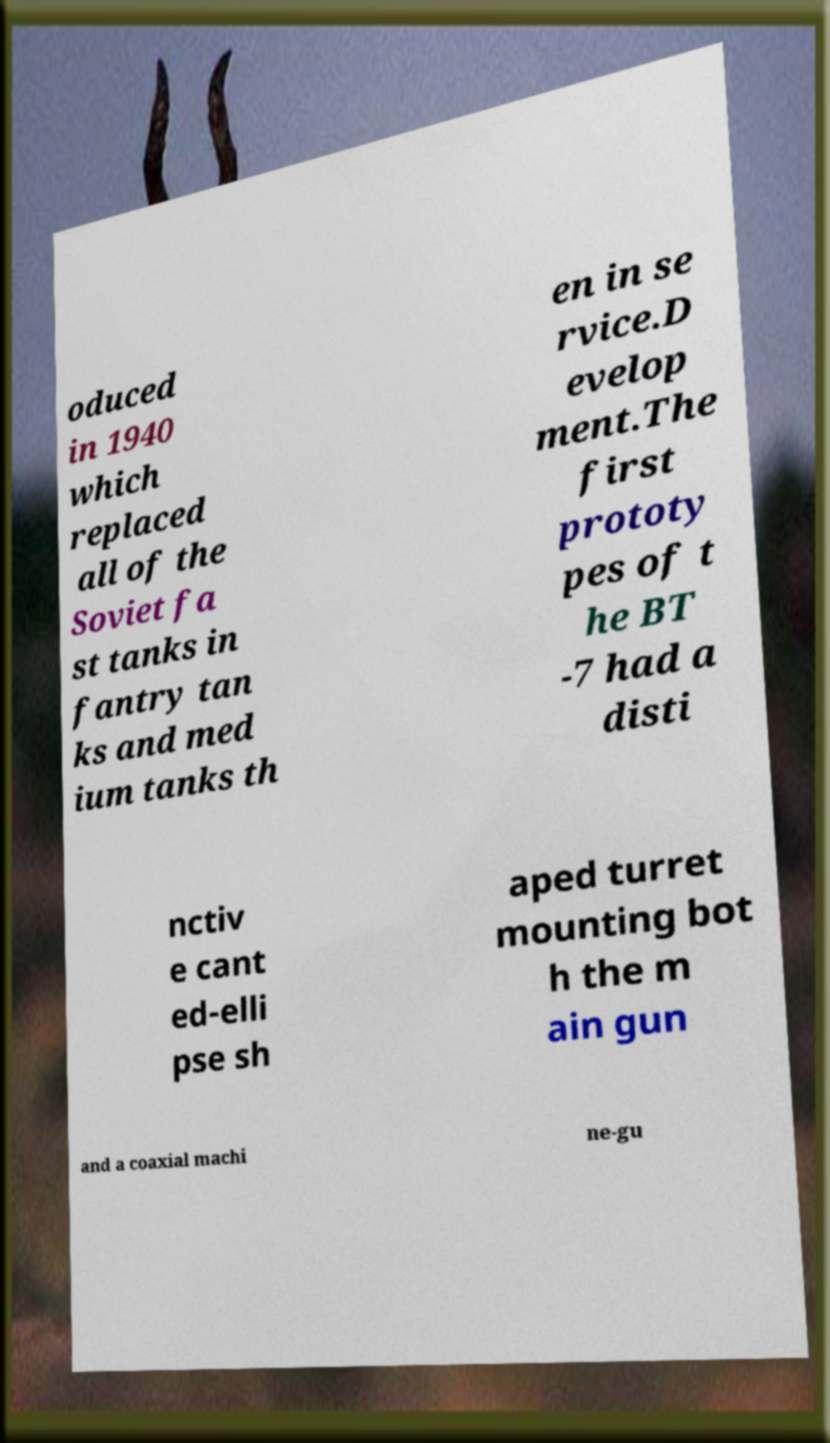For documentation purposes, I need the text within this image transcribed. Could you provide that? oduced in 1940 which replaced all of the Soviet fa st tanks in fantry tan ks and med ium tanks th en in se rvice.D evelop ment.The first prototy pes of t he BT -7 had a disti nctiv e cant ed-elli pse sh aped turret mounting bot h the m ain gun and a coaxial machi ne-gu 